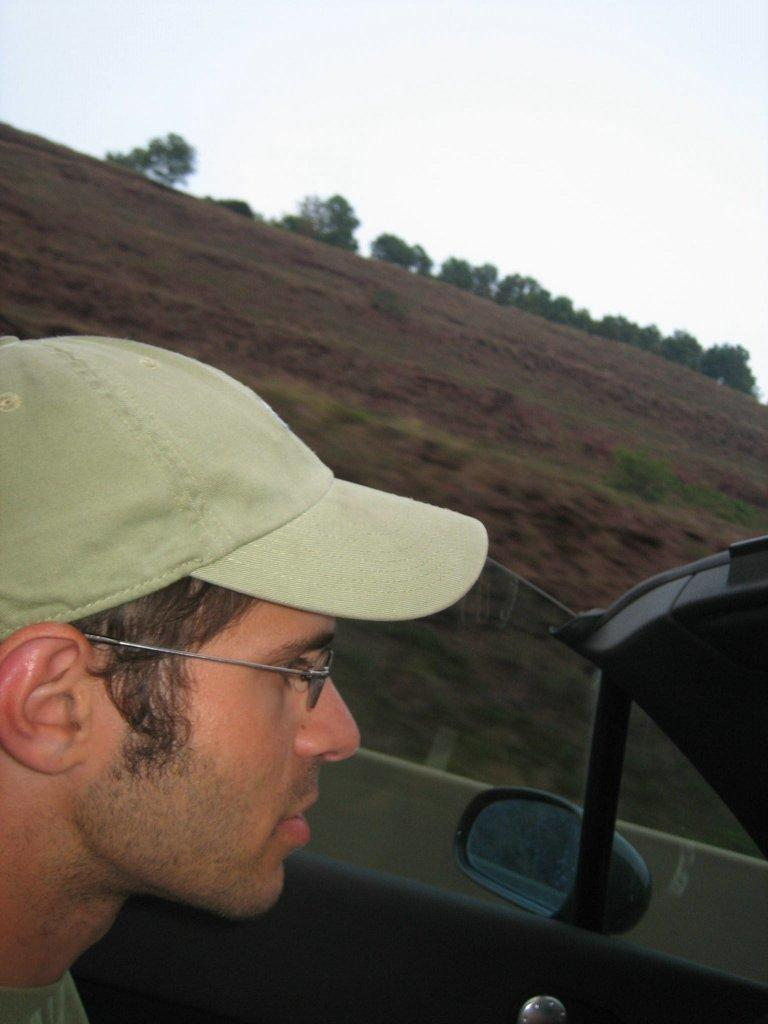What is present in the image? There is a man in the image. Can you describe what the man is wearing? The man is wearing a hat. What is the man doing in the image? The man is sitting in a car. What shape is the car in the image? The provided facts do not mention the shape of the car, so it cannot be determined from the image. What type of plants can be seen growing in the car? There are no plants visible in the car in the image. 